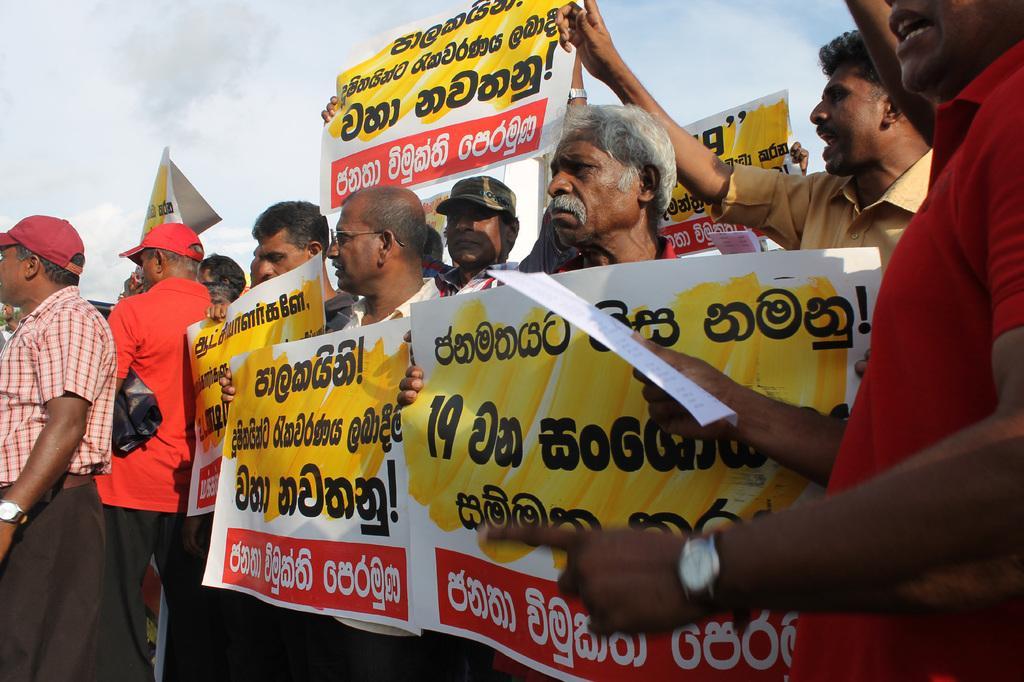Please provide a concise description of this image. There are people holding posters in their hands in the foreground area of the image, there is text on the posters and the sky in the background. 